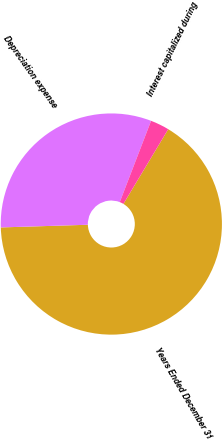Convert chart to OTSL. <chart><loc_0><loc_0><loc_500><loc_500><pie_chart><fcel>Years Ended December 31<fcel>Depreciation expense<fcel>Interest capitalized during<nl><fcel>65.91%<fcel>31.34%<fcel>2.75%<nl></chart> 